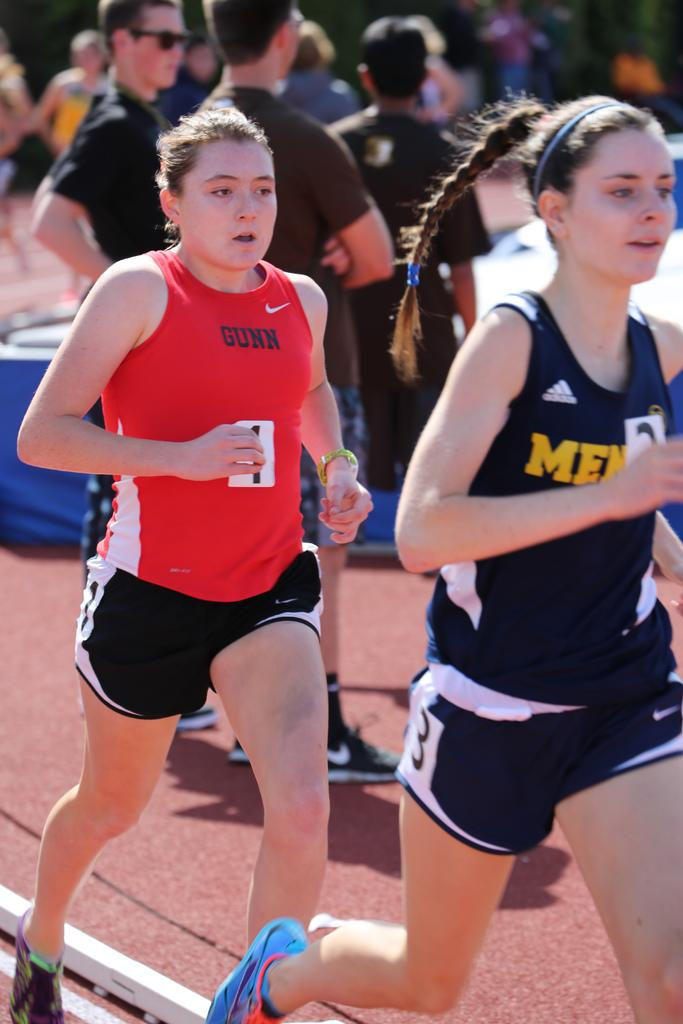<image>
Share a concise interpretation of the image provided. A runner in a red shirt that says Gunn on the front. 